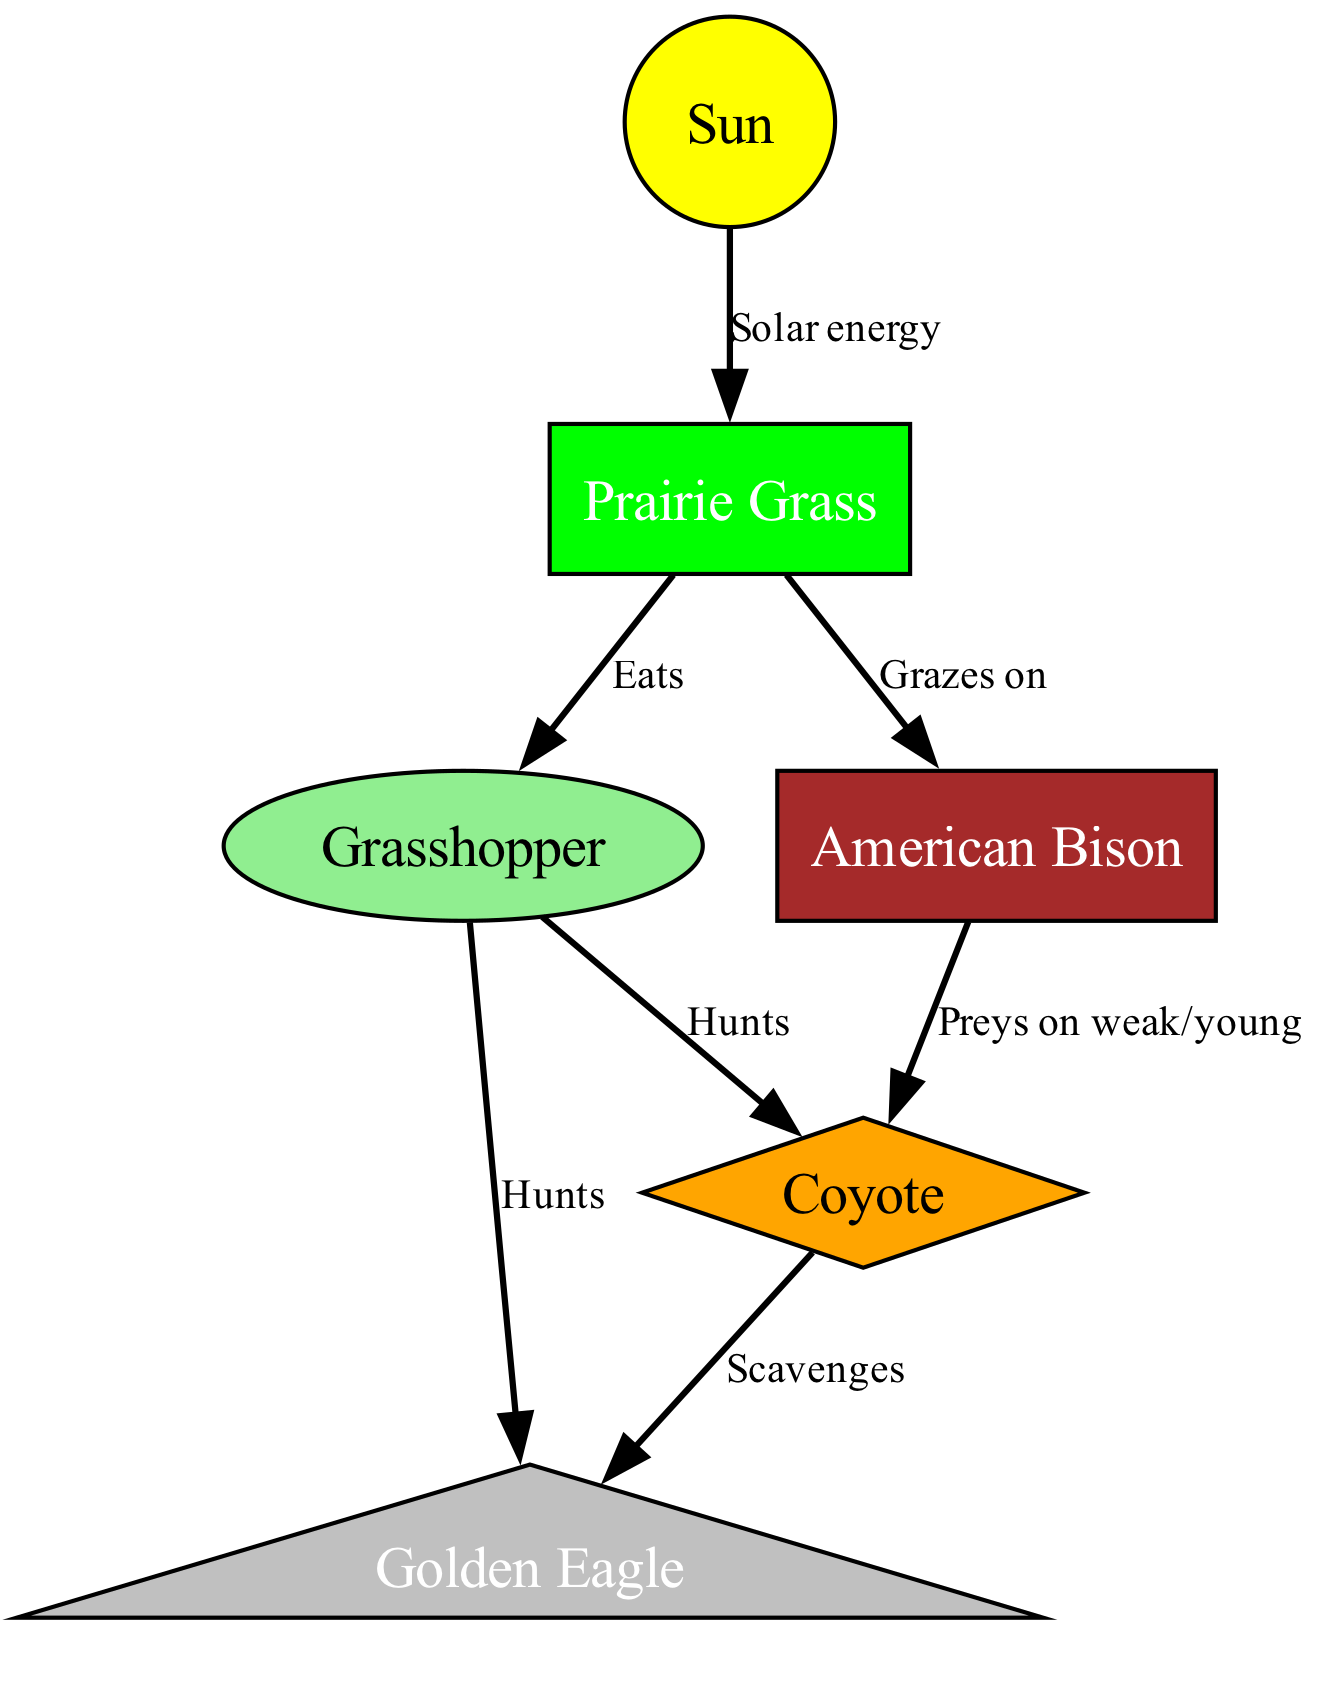What are the primary producers in the diagram? The primary producers are the organisms that produce energy through photosynthesis. In this diagram, the only primary producer mentioned is the Prairie Grass, which receives solar energy from the Sun.
Answer: Prairie Grass How many nodes are in the food chain? By counting each unique entity present in the diagram, we identify six nodes: Sun, Prairie Grass, Grasshopper, American Bison, Coyote, and Golden Eagle, making the total count six.
Answer: 6 What does the Grasshopper eat? The Grasshopper consumes Prairie Grass as indicated by the edge labeled "Eats." This relationship directly connects the Grasshopper to its food source.
Answer: Prairie Grass Which animal hunts the Grasshopper? According to the connections in the diagram, the Coyote and Golden Eagle both hunt the Grasshopper, as indicated by the edges labeled "Hunts." Hence, either can be considered the answer.
Answer: Coyote / Golden Eagle Which animal is perceived as a prey for the Coyote? The diagram shows that the Coyote can hunt both the Grasshopper and can prey upon weak or young American Bison. This indicates the Coyote preys on the Bison as its larger prey.
Answer: American Bison How does energy flow from the Sun to the Eagle? The energy flow starts with the Sun providing solar energy to the Prairie Grass. Then, the Grasshopper, which eats the Grass, becomes prey for the Eagle. The Coyote also hunts the Grasshopper, but both Energy flows ultimately reaches the Eagle through this chain: Sun → Grass → Grasshopper → Eagle.
Answer: Sun → Grass → Grasshopper → Eagle What is a scavenger in this diagram? The Coyote is identified as a scavenger in this ecosystem, feeding on the remains of other animals. The diagram states this with the labeling "Scavenges," indicating that the Coyote participates in this role.
Answer: Coyote How many carnivores are present in the food chain? Reviewing the diagram, the Coyote and Golden Eagle are both classified as carnivores, as they hunt other animals for food. Counting both gives a total of two carnivores in the food chain.
Answer: 2 What role do grazing animals play in this food chain? Grazing animals such as the American Bison consume grass, which positions them as primary consumers in the food chain. Their feeding habits directly convert the grass energy into a form that can be utilized by carnivores.
Answer: Primary consumers 